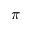Convert formula to latex. <formula><loc_0><loc_0><loc_500><loc_500>\pi</formula> 